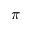Convert formula to latex. <formula><loc_0><loc_0><loc_500><loc_500>\pi</formula> 